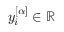Convert formula to latex. <formula><loc_0><loc_0><loc_500><loc_500>y _ { i } ^ { [ \alpha ] } \in \mathbb { R }</formula> 